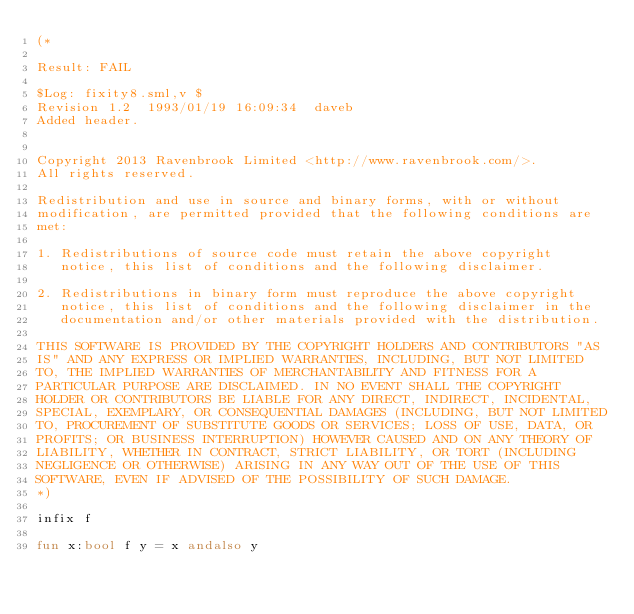<code> <loc_0><loc_0><loc_500><loc_500><_SML_>(*

Result: FAIL
 
$Log: fixity8.sml,v $
Revision 1.2  1993/01/19 16:09:34  daveb
Added header.


Copyright 2013 Ravenbrook Limited <http://www.ravenbrook.com/>.
All rights reserved.

Redistribution and use in source and binary forms, with or without
modification, are permitted provided that the following conditions are
met:

1. Redistributions of source code must retain the above copyright
   notice, this list of conditions and the following disclaimer.

2. Redistributions in binary form must reproduce the above copyright
   notice, this list of conditions and the following disclaimer in the
   documentation and/or other materials provided with the distribution.

THIS SOFTWARE IS PROVIDED BY THE COPYRIGHT HOLDERS AND CONTRIBUTORS "AS
IS" AND ANY EXPRESS OR IMPLIED WARRANTIES, INCLUDING, BUT NOT LIMITED
TO, THE IMPLIED WARRANTIES OF MERCHANTABILITY AND FITNESS FOR A
PARTICULAR PURPOSE ARE DISCLAIMED. IN NO EVENT SHALL THE COPYRIGHT
HOLDER OR CONTRIBUTORS BE LIABLE FOR ANY DIRECT, INDIRECT, INCIDENTAL,
SPECIAL, EXEMPLARY, OR CONSEQUENTIAL DAMAGES (INCLUDING, BUT NOT LIMITED
TO, PROCUREMENT OF SUBSTITUTE GOODS OR SERVICES; LOSS OF USE, DATA, OR
PROFITS; OR BUSINESS INTERRUPTION) HOWEVER CAUSED AND ON ANY THEORY OF
LIABILITY, WHETHER IN CONTRACT, STRICT LIABILITY, OR TORT (INCLUDING
NEGLIGENCE OR OTHERWISE) ARISING IN ANY WAY OUT OF THE USE OF THIS
SOFTWARE, EVEN IF ADVISED OF THE POSSIBILITY OF SUCH DAMAGE.
*)

infix f

fun x:bool f y = x andalso y
</code> 